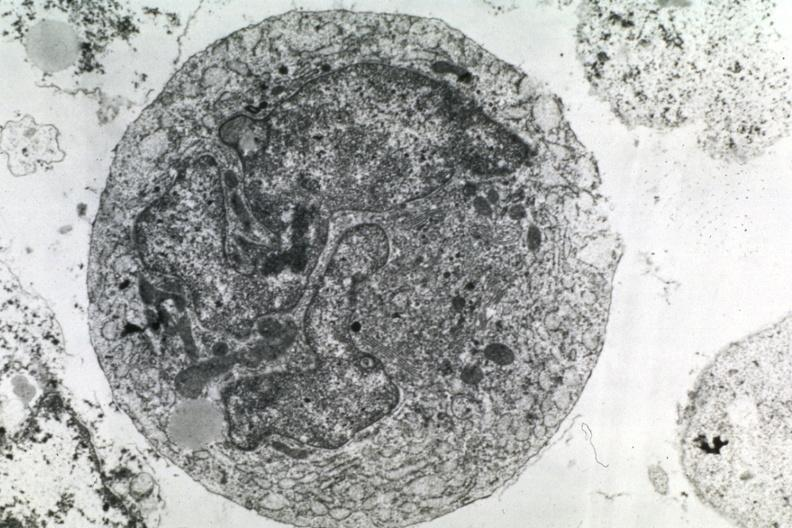does 7182 and 7183 show dr garcia tumors 50?
Answer the question using a single word or phrase. No 